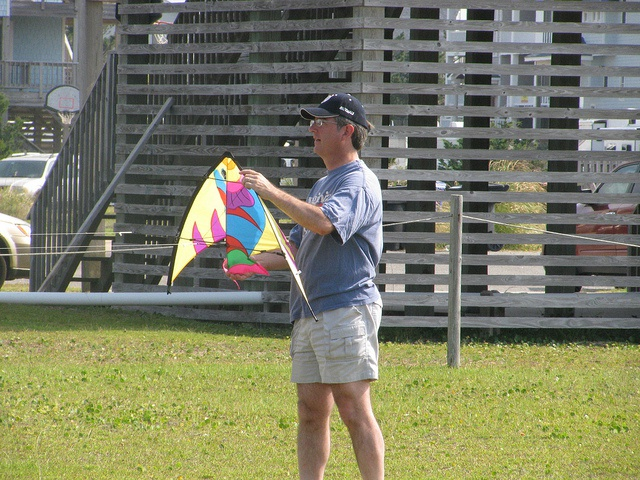Describe the objects in this image and their specific colors. I can see people in darkgray, gray, and lightgray tones, kite in darkgray, lightyellow, khaki, lightblue, and gray tones, car in darkgray, gray, black, and maroon tones, car in darkgray, white, and gray tones, and car in darkgray, white, black, gray, and darkgreen tones in this image. 